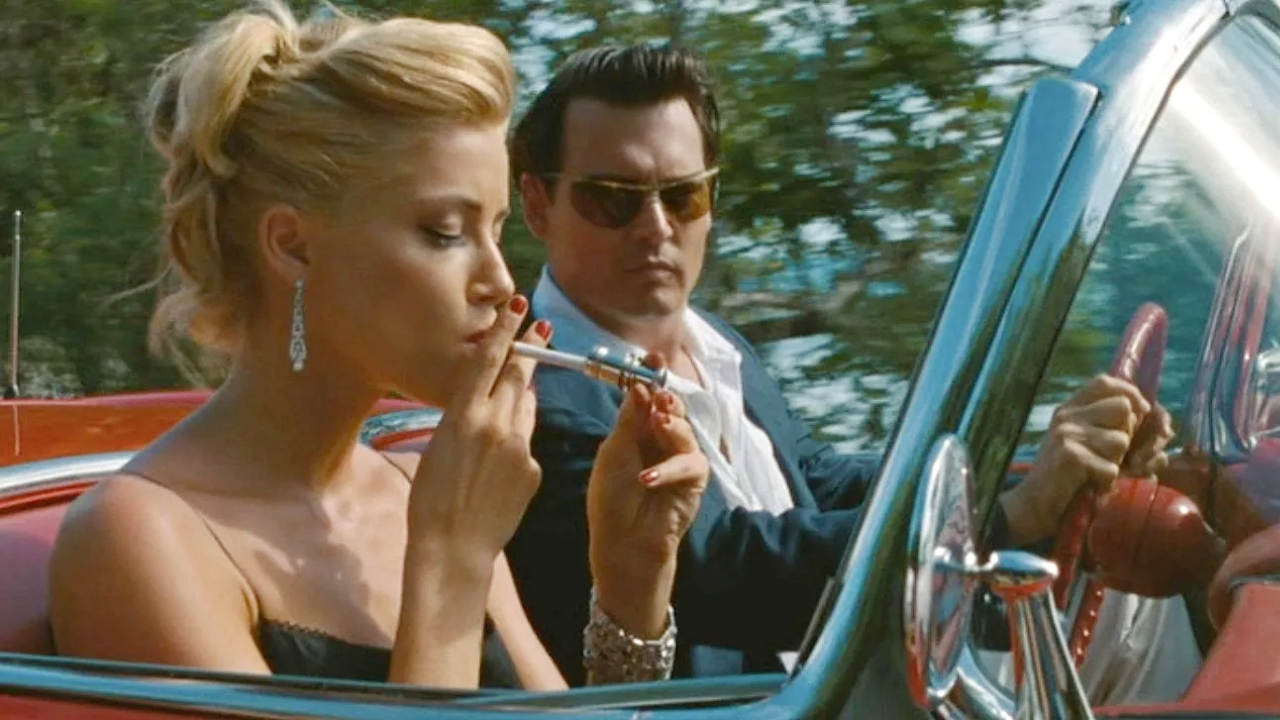What does the style of clothing suggest about the characters? Chenault’s elegant gold dress and jewelry suggest sophistication and a connection to the wealthier class, aligning with her character's background and the social setting of the 1960s. Paul Kemp’s black suit and sunglasses indicate a typical journalistic or intellectual persona, implying a serious nature and perhaps a hidden depth or personal agenda. How does Chenault smoking affect her character portrayal? Her smoking adds a layer of complexity and defiance to her character. It signifies a liberal attitude and possibly an attempt to assert her independence and modernity in a period of significant social change. This action might also be used to convey an aura of stress or contemplation, deepening her character's narrative in the film. 